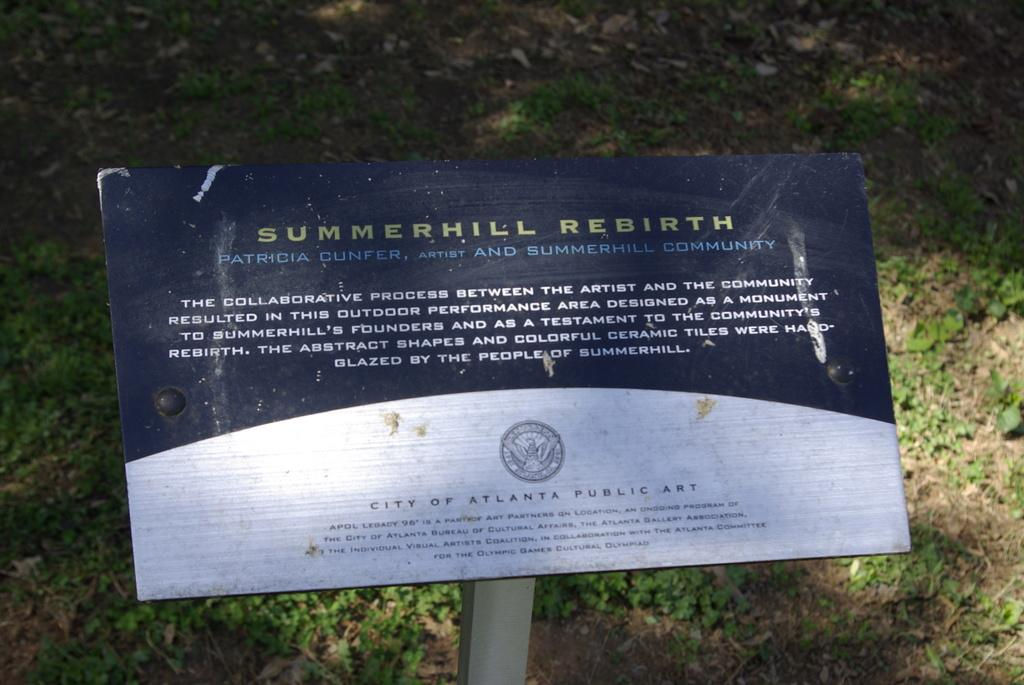What is on the board that is visible in the image? There is text on the board in the image. What type of surface is visible on the ground in the image? There is grass on the ground in the image. How does the suggestion move around in the image? There is no suggestion present in the image, so it cannot move around. 